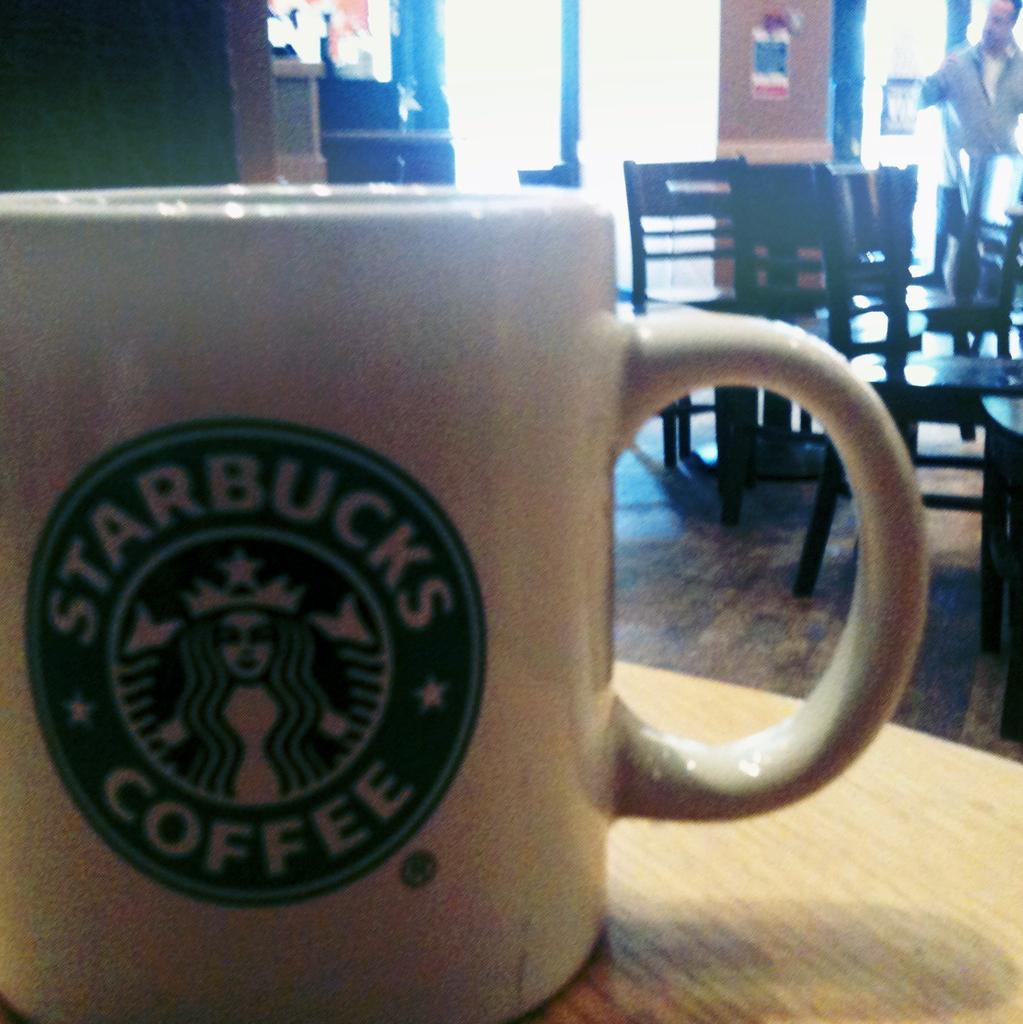In one or two sentences, can you explain what this image depicts? The picture consists of one starbucks cup on the table and behind that there are chairs and one person is standing at the right corner the picture and there is one window and a wall. 